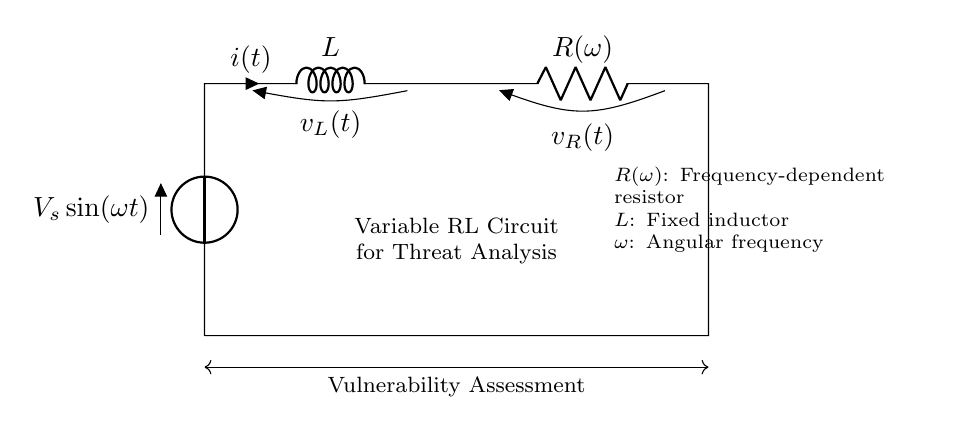What components are in this circuit? The components visible in the circuit diagram include a voltage source, an inductor, and a variable resistor.
Answer: voltage source, inductor, variable resistor What is the voltage source function? The voltage source is described as a sinusoidal function, \( V_s \sin(\omega t) \), indicating it provides an alternating current with a specific angular frequency.
Answer: sinusoidal function What does the inductor represent in this circuit? The inductor represents a storage component of energy in the magnetic field as current passes through it, characterized by the inductance value 'L'.
Answer: energy storage How does the resistance change in this circuit? The resistance changes as a function of angular frequency, denoted as R(omega), indicating frequency-dependent resistance behavior in the circuit.
Answer: frequency-dependent What is the role of the circuit in threat analysis? This circuit is used to simulate and analyze vulnerabilities in electrical systems by observing the behavior of the RL circuit under varying frequencies.
Answer: simulate vulnerabilities What happens to the current in this circuit at high frequencies? At high frequencies, the inductor will oppose the change in current due to its inductance, resulting in a reduction in the overall current through the circuit.
Answer: reduced current How does the variable resistor affect circuit behavior? The variable resistor allows for tuning the resistance level, thereby affecting the voltage drop across itself and the overall circuit response to the applied voltage source.
Answer: tuning resistance 